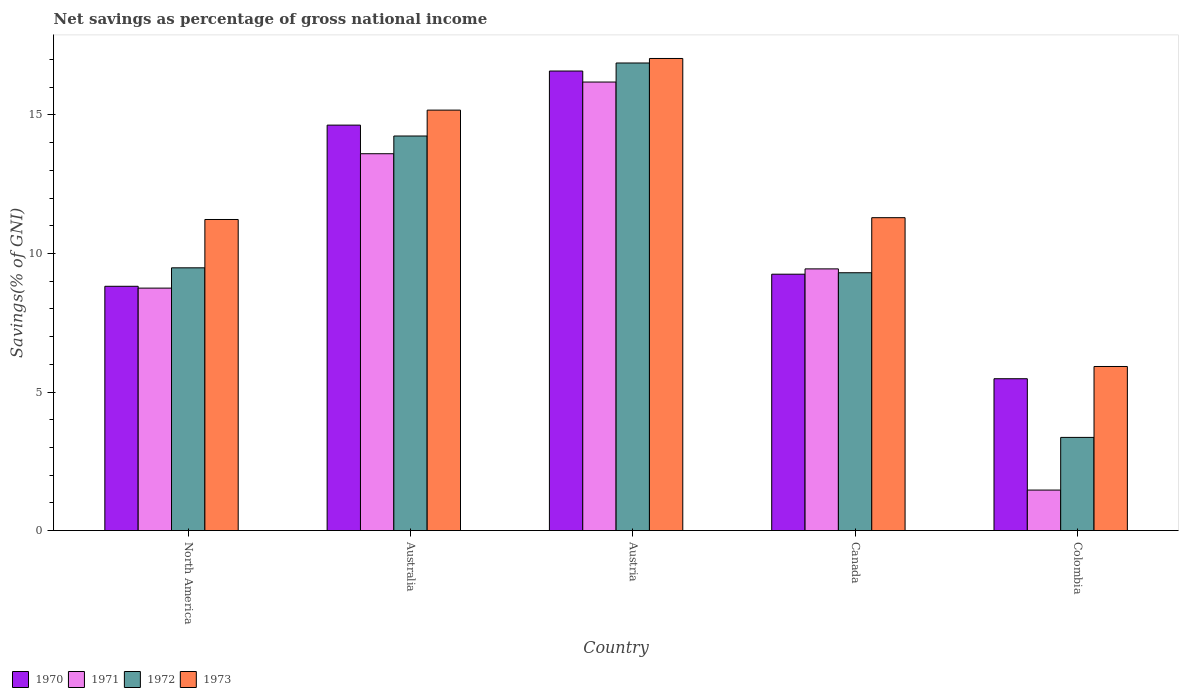Are the number of bars on each tick of the X-axis equal?
Your response must be concise. Yes. How many bars are there on the 3rd tick from the right?
Provide a short and direct response. 4. In how many cases, is the number of bars for a given country not equal to the number of legend labels?
Give a very brief answer. 0. What is the total savings in 1970 in Austria?
Your answer should be very brief. 16.59. Across all countries, what is the maximum total savings in 1970?
Your answer should be compact. 16.59. Across all countries, what is the minimum total savings in 1973?
Ensure brevity in your answer.  5.92. In which country was the total savings in 1971 maximum?
Your answer should be very brief. Austria. What is the total total savings in 1970 in the graph?
Keep it short and to the point. 54.78. What is the difference between the total savings in 1970 in Canada and that in North America?
Offer a very short reply. 0.44. What is the difference between the total savings in 1970 in North America and the total savings in 1971 in Australia?
Your answer should be compact. -4.78. What is the average total savings in 1970 per country?
Make the answer very short. 10.96. What is the difference between the total savings of/in 1970 and total savings of/in 1973 in Austria?
Ensure brevity in your answer.  -0.45. In how many countries, is the total savings in 1970 greater than 5 %?
Keep it short and to the point. 5. What is the ratio of the total savings in 1971 in Austria to that in Canada?
Provide a succinct answer. 1.71. Is the difference between the total savings in 1970 in Australia and North America greater than the difference between the total savings in 1973 in Australia and North America?
Provide a succinct answer. Yes. What is the difference between the highest and the second highest total savings in 1972?
Ensure brevity in your answer.  7.39. What is the difference between the highest and the lowest total savings in 1973?
Your answer should be compact. 11.12. In how many countries, is the total savings in 1971 greater than the average total savings in 1971 taken over all countries?
Offer a very short reply. 2. Is the sum of the total savings in 1971 in Australia and Austria greater than the maximum total savings in 1972 across all countries?
Provide a succinct answer. Yes. What does the 3rd bar from the left in Australia represents?
Your answer should be very brief. 1972. What does the 3rd bar from the right in Colombia represents?
Your answer should be compact. 1971. Is it the case that in every country, the sum of the total savings in 1973 and total savings in 1971 is greater than the total savings in 1972?
Offer a terse response. Yes. How many countries are there in the graph?
Ensure brevity in your answer.  5. What is the difference between two consecutive major ticks on the Y-axis?
Your answer should be compact. 5. Does the graph contain any zero values?
Provide a succinct answer. No. Does the graph contain grids?
Your answer should be very brief. No. Where does the legend appear in the graph?
Your response must be concise. Bottom left. How many legend labels are there?
Provide a short and direct response. 4. What is the title of the graph?
Ensure brevity in your answer.  Net savings as percentage of gross national income. Does "2001" appear as one of the legend labels in the graph?
Provide a short and direct response. No. What is the label or title of the X-axis?
Your response must be concise. Country. What is the label or title of the Y-axis?
Ensure brevity in your answer.  Savings(% of GNI). What is the Savings(% of GNI) of 1970 in North America?
Ensure brevity in your answer.  8.82. What is the Savings(% of GNI) of 1971 in North America?
Your response must be concise. 8.75. What is the Savings(% of GNI) in 1972 in North America?
Keep it short and to the point. 9.48. What is the Savings(% of GNI) in 1973 in North America?
Ensure brevity in your answer.  11.23. What is the Savings(% of GNI) in 1970 in Australia?
Ensure brevity in your answer.  14.63. What is the Savings(% of GNI) of 1971 in Australia?
Your answer should be very brief. 13.6. What is the Savings(% of GNI) of 1972 in Australia?
Provide a succinct answer. 14.24. What is the Savings(% of GNI) of 1973 in Australia?
Offer a very short reply. 15.18. What is the Savings(% of GNI) in 1970 in Austria?
Your answer should be compact. 16.59. What is the Savings(% of GNI) in 1971 in Austria?
Offer a very short reply. 16.19. What is the Savings(% of GNI) of 1972 in Austria?
Your answer should be very brief. 16.88. What is the Savings(% of GNI) of 1973 in Austria?
Your answer should be compact. 17.04. What is the Savings(% of GNI) of 1970 in Canada?
Offer a very short reply. 9.25. What is the Savings(% of GNI) of 1971 in Canada?
Your answer should be very brief. 9.45. What is the Savings(% of GNI) of 1972 in Canada?
Offer a very short reply. 9.31. What is the Savings(% of GNI) of 1973 in Canada?
Keep it short and to the point. 11.29. What is the Savings(% of GNI) in 1970 in Colombia?
Provide a succinct answer. 5.48. What is the Savings(% of GNI) of 1971 in Colombia?
Ensure brevity in your answer.  1.46. What is the Savings(% of GNI) of 1972 in Colombia?
Your response must be concise. 3.36. What is the Savings(% of GNI) in 1973 in Colombia?
Give a very brief answer. 5.92. Across all countries, what is the maximum Savings(% of GNI) in 1970?
Ensure brevity in your answer.  16.59. Across all countries, what is the maximum Savings(% of GNI) in 1971?
Your answer should be very brief. 16.19. Across all countries, what is the maximum Savings(% of GNI) in 1972?
Offer a terse response. 16.88. Across all countries, what is the maximum Savings(% of GNI) of 1973?
Your answer should be compact. 17.04. Across all countries, what is the minimum Savings(% of GNI) of 1970?
Provide a short and direct response. 5.48. Across all countries, what is the minimum Savings(% of GNI) of 1971?
Offer a very short reply. 1.46. Across all countries, what is the minimum Savings(% of GNI) in 1972?
Your answer should be compact. 3.36. Across all countries, what is the minimum Savings(% of GNI) in 1973?
Provide a succinct answer. 5.92. What is the total Savings(% of GNI) in 1970 in the graph?
Ensure brevity in your answer.  54.78. What is the total Savings(% of GNI) in 1971 in the graph?
Provide a succinct answer. 49.45. What is the total Savings(% of GNI) in 1972 in the graph?
Make the answer very short. 53.27. What is the total Savings(% of GNI) of 1973 in the graph?
Provide a succinct answer. 60.66. What is the difference between the Savings(% of GNI) of 1970 in North America and that in Australia?
Your answer should be very brief. -5.82. What is the difference between the Savings(% of GNI) of 1971 in North America and that in Australia?
Make the answer very short. -4.85. What is the difference between the Savings(% of GNI) in 1972 in North America and that in Australia?
Offer a very short reply. -4.76. What is the difference between the Savings(% of GNI) of 1973 in North America and that in Australia?
Give a very brief answer. -3.95. What is the difference between the Savings(% of GNI) of 1970 in North America and that in Austria?
Offer a very short reply. -7.77. What is the difference between the Savings(% of GNI) of 1971 in North America and that in Austria?
Offer a terse response. -7.44. What is the difference between the Savings(% of GNI) of 1972 in North America and that in Austria?
Give a very brief answer. -7.39. What is the difference between the Savings(% of GNI) in 1973 in North America and that in Austria?
Provide a short and direct response. -5.81. What is the difference between the Savings(% of GNI) of 1970 in North America and that in Canada?
Give a very brief answer. -0.44. What is the difference between the Savings(% of GNI) of 1971 in North America and that in Canada?
Keep it short and to the point. -0.69. What is the difference between the Savings(% of GNI) of 1972 in North America and that in Canada?
Make the answer very short. 0.18. What is the difference between the Savings(% of GNI) of 1973 in North America and that in Canada?
Provide a short and direct response. -0.07. What is the difference between the Savings(% of GNI) in 1970 in North America and that in Colombia?
Offer a very short reply. 3.34. What is the difference between the Savings(% of GNI) of 1971 in North America and that in Colombia?
Your answer should be compact. 7.29. What is the difference between the Savings(% of GNI) in 1972 in North America and that in Colombia?
Offer a terse response. 6.12. What is the difference between the Savings(% of GNI) of 1973 in North America and that in Colombia?
Ensure brevity in your answer.  5.31. What is the difference between the Savings(% of GNI) in 1970 in Australia and that in Austria?
Provide a short and direct response. -1.95. What is the difference between the Savings(% of GNI) of 1971 in Australia and that in Austria?
Provide a short and direct response. -2.59. What is the difference between the Savings(% of GNI) in 1972 in Australia and that in Austria?
Keep it short and to the point. -2.64. What is the difference between the Savings(% of GNI) in 1973 in Australia and that in Austria?
Offer a very short reply. -1.86. What is the difference between the Savings(% of GNI) in 1970 in Australia and that in Canada?
Give a very brief answer. 5.38. What is the difference between the Savings(% of GNI) of 1971 in Australia and that in Canada?
Provide a succinct answer. 4.16. What is the difference between the Savings(% of GNI) of 1972 in Australia and that in Canada?
Offer a terse response. 4.93. What is the difference between the Savings(% of GNI) in 1973 in Australia and that in Canada?
Give a very brief answer. 3.88. What is the difference between the Savings(% of GNI) of 1970 in Australia and that in Colombia?
Provide a succinct answer. 9.15. What is the difference between the Savings(% of GNI) in 1971 in Australia and that in Colombia?
Ensure brevity in your answer.  12.14. What is the difference between the Savings(% of GNI) in 1972 in Australia and that in Colombia?
Keep it short and to the point. 10.88. What is the difference between the Savings(% of GNI) of 1973 in Australia and that in Colombia?
Your answer should be very brief. 9.25. What is the difference between the Savings(% of GNI) in 1970 in Austria and that in Canada?
Provide a short and direct response. 7.33. What is the difference between the Savings(% of GNI) in 1971 in Austria and that in Canada?
Make the answer very short. 6.74. What is the difference between the Savings(% of GNI) of 1972 in Austria and that in Canada?
Provide a succinct answer. 7.57. What is the difference between the Savings(% of GNI) in 1973 in Austria and that in Canada?
Offer a very short reply. 5.75. What is the difference between the Savings(% of GNI) in 1970 in Austria and that in Colombia?
Your answer should be compact. 11.11. What is the difference between the Savings(% of GNI) of 1971 in Austria and that in Colombia?
Make the answer very short. 14.73. What is the difference between the Savings(% of GNI) in 1972 in Austria and that in Colombia?
Your answer should be compact. 13.51. What is the difference between the Savings(% of GNI) of 1973 in Austria and that in Colombia?
Offer a terse response. 11.12. What is the difference between the Savings(% of GNI) in 1970 in Canada and that in Colombia?
Keep it short and to the point. 3.77. What is the difference between the Savings(% of GNI) of 1971 in Canada and that in Colombia?
Give a very brief answer. 7.98. What is the difference between the Savings(% of GNI) of 1972 in Canada and that in Colombia?
Give a very brief answer. 5.94. What is the difference between the Savings(% of GNI) in 1973 in Canada and that in Colombia?
Your response must be concise. 5.37. What is the difference between the Savings(% of GNI) of 1970 in North America and the Savings(% of GNI) of 1971 in Australia?
Make the answer very short. -4.78. What is the difference between the Savings(% of GNI) in 1970 in North America and the Savings(% of GNI) in 1972 in Australia?
Make the answer very short. -5.42. What is the difference between the Savings(% of GNI) of 1970 in North America and the Savings(% of GNI) of 1973 in Australia?
Offer a terse response. -6.36. What is the difference between the Savings(% of GNI) of 1971 in North America and the Savings(% of GNI) of 1972 in Australia?
Your response must be concise. -5.49. What is the difference between the Savings(% of GNI) of 1971 in North America and the Savings(% of GNI) of 1973 in Australia?
Your answer should be compact. -6.42. What is the difference between the Savings(% of GNI) in 1972 in North America and the Savings(% of GNI) in 1973 in Australia?
Your answer should be very brief. -5.69. What is the difference between the Savings(% of GNI) of 1970 in North America and the Savings(% of GNI) of 1971 in Austria?
Keep it short and to the point. -7.37. What is the difference between the Savings(% of GNI) of 1970 in North America and the Savings(% of GNI) of 1972 in Austria?
Ensure brevity in your answer.  -8.06. What is the difference between the Savings(% of GNI) in 1970 in North America and the Savings(% of GNI) in 1973 in Austria?
Offer a terse response. -8.22. What is the difference between the Savings(% of GNI) of 1971 in North America and the Savings(% of GNI) of 1972 in Austria?
Keep it short and to the point. -8.12. What is the difference between the Savings(% of GNI) of 1971 in North America and the Savings(% of GNI) of 1973 in Austria?
Your response must be concise. -8.29. What is the difference between the Savings(% of GNI) in 1972 in North America and the Savings(% of GNI) in 1973 in Austria?
Give a very brief answer. -7.56. What is the difference between the Savings(% of GNI) in 1970 in North America and the Savings(% of GNI) in 1971 in Canada?
Offer a terse response. -0.63. What is the difference between the Savings(% of GNI) in 1970 in North America and the Savings(% of GNI) in 1972 in Canada?
Your response must be concise. -0.49. What is the difference between the Savings(% of GNI) in 1970 in North America and the Savings(% of GNI) in 1973 in Canada?
Make the answer very short. -2.48. What is the difference between the Savings(% of GNI) of 1971 in North America and the Savings(% of GNI) of 1972 in Canada?
Your answer should be very brief. -0.55. What is the difference between the Savings(% of GNI) of 1971 in North America and the Savings(% of GNI) of 1973 in Canada?
Give a very brief answer. -2.54. What is the difference between the Savings(% of GNI) in 1972 in North America and the Savings(% of GNI) in 1973 in Canada?
Ensure brevity in your answer.  -1.81. What is the difference between the Savings(% of GNI) of 1970 in North America and the Savings(% of GNI) of 1971 in Colombia?
Your answer should be very brief. 7.36. What is the difference between the Savings(% of GNI) of 1970 in North America and the Savings(% of GNI) of 1972 in Colombia?
Provide a short and direct response. 5.45. What is the difference between the Savings(% of GNI) of 1970 in North America and the Savings(% of GNI) of 1973 in Colombia?
Your response must be concise. 2.89. What is the difference between the Savings(% of GNI) in 1971 in North America and the Savings(% of GNI) in 1972 in Colombia?
Make the answer very short. 5.39. What is the difference between the Savings(% of GNI) in 1971 in North America and the Savings(% of GNI) in 1973 in Colombia?
Make the answer very short. 2.83. What is the difference between the Savings(% of GNI) of 1972 in North America and the Savings(% of GNI) of 1973 in Colombia?
Ensure brevity in your answer.  3.56. What is the difference between the Savings(% of GNI) in 1970 in Australia and the Savings(% of GNI) in 1971 in Austria?
Provide a short and direct response. -1.55. What is the difference between the Savings(% of GNI) in 1970 in Australia and the Savings(% of GNI) in 1972 in Austria?
Offer a very short reply. -2.24. What is the difference between the Savings(% of GNI) in 1970 in Australia and the Savings(% of GNI) in 1973 in Austria?
Provide a succinct answer. -2.4. What is the difference between the Savings(% of GNI) of 1971 in Australia and the Savings(% of GNI) of 1972 in Austria?
Ensure brevity in your answer.  -3.27. What is the difference between the Savings(% of GNI) in 1971 in Australia and the Savings(% of GNI) in 1973 in Austria?
Your response must be concise. -3.44. What is the difference between the Savings(% of GNI) in 1972 in Australia and the Savings(% of GNI) in 1973 in Austria?
Offer a terse response. -2.8. What is the difference between the Savings(% of GNI) in 1970 in Australia and the Savings(% of GNI) in 1971 in Canada?
Give a very brief answer. 5.19. What is the difference between the Savings(% of GNI) of 1970 in Australia and the Savings(% of GNI) of 1972 in Canada?
Give a very brief answer. 5.33. What is the difference between the Savings(% of GNI) in 1970 in Australia and the Savings(% of GNI) in 1973 in Canada?
Give a very brief answer. 3.34. What is the difference between the Savings(% of GNI) in 1971 in Australia and the Savings(% of GNI) in 1972 in Canada?
Offer a terse response. 4.3. What is the difference between the Savings(% of GNI) in 1971 in Australia and the Savings(% of GNI) in 1973 in Canada?
Keep it short and to the point. 2.31. What is the difference between the Savings(% of GNI) of 1972 in Australia and the Savings(% of GNI) of 1973 in Canada?
Offer a very short reply. 2.95. What is the difference between the Savings(% of GNI) of 1970 in Australia and the Savings(% of GNI) of 1971 in Colombia?
Keep it short and to the point. 13.17. What is the difference between the Savings(% of GNI) of 1970 in Australia and the Savings(% of GNI) of 1972 in Colombia?
Provide a short and direct response. 11.27. What is the difference between the Savings(% of GNI) of 1970 in Australia and the Savings(% of GNI) of 1973 in Colombia?
Give a very brief answer. 8.71. What is the difference between the Savings(% of GNI) in 1971 in Australia and the Savings(% of GNI) in 1972 in Colombia?
Provide a succinct answer. 10.24. What is the difference between the Savings(% of GNI) in 1971 in Australia and the Savings(% of GNI) in 1973 in Colombia?
Give a very brief answer. 7.68. What is the difference between the Savings(% of GNI) of 1972 in Australia and the Savings(% of GNI) of 1973 in Colombia?
Your response must be concise. 8.32. What is the difference between the Savings(% of GNI) in 1970 in Austria and the Savings(% of GNI) in 1971 in Canada?
Your response must be concise. 7.14. What is the difference between the Savings(% of GNI) in 1970 in Austria and the Savings(% of GNI) in 1972 in Canada?
Your response must be concise. 7.28. What is the difference between the Savings(% of GNI) in 1970 in Austria and the Savings(% of GNI) in 1973 in Canada?
Your response must be concise. 5.29. What is the difference between the Savings(% of GNI) of 1971 in Austria and the Savings(% of GNI) of 1972 in Canada?
Provide a succinct answer. 6.88. What is the difference between the Savings(% of GNI) in 1971 in Austria and the Savings(% of GNI) in 1973 in Canada?
Give a very brief answer. 4.9. What is the difference between the Savings(% of GNI) in 1972 in Austria and the Savings(% of GNI) in 1973 in Canada?
Ensure brevity in your answer.  5.58. What is the difference between the Savings(% of GNI) in 1970 in Austria and the Savings(% of GNI) in 1971 in Colombia?
Your response must be concise. 15.12. What is the difference between the Savings(% of GNI) in 1970 in Austria and the Savings(% of GNI) in 1972 in Colombia?
Your answer should be very brief. 13.22. What is the difference between the Savings(% of GNI) in 1970 in Austria and the Savings(% of GNI) in 1973 in Colombia?
Give a very brief answer. 10.66. What is the difference between the Savings(% of GNI) of 1971 in Austria and the Savings(% of GNI) of 1972 in Colombia?
Offer a very short reply. 12.83. What is the difference between the Savings(% of GNI) of 1971 in Austria and the Savings(% of GNI) of 1973 in Colombia?
Ensure brevity in your answer.  10.27. What is the difference between the Savings(% of GNI) in 1972 in Austria and the Savings(% of GNI) in 1973 in Colombia?
Offer a terse response. 10.95. What is the difference between the Savings(% of GNI) in 1970 in Canada and the Savings(% of GNI) in 1971 in Colombia?
Your response must be concise. 7.79. What is the difference between the Savings(% of GNI) in 1970 in Canada and the Savings(% of GNI) in 1972 in Colombia?
Give a very brief answer. 5.89. What is the difference between the Savings(% of GNI) of 1970 in Canada and the Savings(% of GNI) of 1973 in Colombia?
Offer a very short reply. 3.33. What is the difference between the Savings(% of GNI) in 1971 in Canada and the Savings(% of GNI) in 1972 in Colombia?
Your answer should be compact. 6.08. What is the difference between the Savings(% of GNI) in 1971 in Canada and the Savings(% of GNI) in 1973 in Colombia?
Offer a very short reply. 3.52. What is the difference between the Savings(% of GNI) in 1972 in Canada and the Savings(% of GNI) in 1973 in Colombia?
Offer a very short reply. 3.38. What is the average Savings(% of GNI) in 1970 per country?
Offer a very short reply. 10.96. What is the average Savings(% of GNI) of 1971 per country?
Ensure brevity in your answer.  9.89. What is the average Savings(% of GNI) of 1972 per country?
Offer a very short reply. 10.65. What is the average Savings(% of GNI) of 1973 per country?
Your response must be concise. 12.13. What is the difference between the Savings(% of GNI) of 1970 and Savings(% of GNI) of 1971 in North America?
Keep it short and to the point. 0.07. What is the difference between the Savings(% of GNI) of 1970 and Savings(% of GNI) of 1972 in North America?
Make the answer very short. -0.67. What is the difference between the Savings(% of GNI) of 1970 and Savings(% of GNI) of 1973 in North America?
Your response must be concise. -2.41. What is the difference between the Savings(% of GNI) in 1971 and Savings(% of GNI) in 1972 in North America?
Provide a short and direct response. -0.73. What is the difference between the Savings(% of GNI) of 1971 and Savings(% of GNI) of 1973 in North America?
Make the answer very short. -2.48. What is the difference between the Savings(% of GNI) in 1972 and Savings(% of GNI) in 1973 in North America?
Your answer should be compact. -1.74. What is the difference between the Savings(% of GNI) of 1970 and Savings(% of GNI) of 1971 in Australia?
Your answer should be compact. 1.03. What is the difference between the Savings(% of GNI) of 1970 and Savings(% of GNI) of 1972 in Australia?
Your answer should be very brief. 0.39. What is the difference between the Savings(% of GNI) of 1970 and Savings(% of GNI) of 1973 in Australia?
Offer a very short reply. -0.54. What is the difference between the Savings(% of GNI) in 1971 and Savings(% of GNI) in 1972 in Australia?
Make the answer very short. -0.64. What is the difference between the Savings(% of GNI) in 1971 and Savings(% of GNI) in 1973 in Australia?
Give a very brief answer. -1.57. What is the difference between the Savings(% of GNI) of 1972 and Savings(% of GNI) of 1973 in Australia?
Provide a short and direct response. -0.93. What is the difference between the Savings(% of GNI) in 1970 and Savings(% of GNI) in 1971 in Austria?
Give a very brief answer. 0.4. What is the difference between the Savings(% of GNI) in 1970 and Savings(% of GNI) in 1972 in Austria?
Make the answer very short. -0.29. What is the difference between the Savings(% of GNI) in 1970 and Savings(% of GNI) in 1973 in Austria?
Give a very brief answer. -0.45. What is the difference between the Savings(% of GNI) in 1971 and Savings(% of GNI) in 1972 in Austria?
Provide a succinct answer. -0.69. What is the difference between the Savings(% of GNI) of 1971 and Savings(% of GNI) of 1973 in Austria?
Offer a terse response. -0.85. What is the difference between the Savings(% of GNI) of 1972 and Savings(% of GNI) of 1973 in Austria?
Offer a very short reply. -0.16. What is the difference between the Savings(% of GNI) of 1970 and Savings(% of GNI) of 1971 in Canada?
Your answer should be very brief. -0.19. What is the difference between the Savings(% of GNI) in 1970 and Savings(% of GNI) in 1972 in Canada?
Your answer should be compact. -0.05. What is the difference between the Savings(% of GNI) of 1970 and Savings(% of GNI) of 1973 in Canada?
Give a very brief answer. -2.04. What is the difference between the Savings(% of GNI) in 1971 and Savings(% of GNI) in 1972 in Canada?
Ensure brevity in your answer.  0.14. What is the difference between the Savings(% of GNI) in 1971 and Savings(% of GNI) in 1973 in Canada?
Your response must be concise. -1.85. What is the difference between the Savings(% of GNI) in 1972 and Savings(% of GNI) in 1973 in Canada?
Keep it short and to the point. -1.99. What is the difference between the Savings(% of GNI) of 1970 and Savings(% of GNI) of 1971 in Colombia?
Your answer should be compact. 4.02. What is the difference between the Savings(% of GNI) of 1970 and Savings(% of GNI) of 1972 in Colombia?
Your answer should be very brief. 2.12. What is the difference between the Savings(% of GNI) of 1970 and Savings(% of GNI) of 1973 in Colombia?
Give a very brief answer. -0.44. What is the difference between the Savings(% of GNI) of 1971 and Savings(% of GNI) of 1972 in Colombia?
Provide a short and direct response. -1.9. What is the difference between the Savings(% of GNI) of 1971 and Savings(% of GNI) of 1973 in Colombia?
Your answer should be compact. -4.46. What is the difference between the Savings(% of GNI) in 1972 and Savings(% of GNI) in 1973 in Colombia?
Your answer should be compact. -2.56. What is the ratio of the Savings(% of GNI) in 1970 in North America to that in Australia?
Provide a succinct answer. 0.6. What is the ratio of the Savings(% of GNI) in 1971 in North America to that in Australia?
Your answer should be compact. 0.64. What is the ratio of the Savings(% of GNI) in 1972 in North America to that in Australia?
Keep it short and to the point. 0.67. What is the ratio of the Savings(% of GNI) in 1973 in North America to that in Australia?
Provide a short and direct response. 0.74. What is the ratio of the Savings(% of GNI) of 1970 in North America to that in Austria?
Provide a succinct answer. 0.53. What is the ratio of the Savings(% of GNI) in 1971 in North America to that in Austria?
Give a very brief answer. 0.54. What is the ratio of the Savings(% of GNI) of 1972 in North America to that in Austria?
Ensure brevity in your answer.  0.56. What is the ratio of the Savings(% of GNI) in 1973 in North America to that in Austria?
Your response must be concise. 0.66. What is the ratio of the Savings(% of GNI) of 1970 in North America to that in Canada?
Provide a short and direct response. 0.95. What is the ratio of the Savings(% of GNI) in 1971 in North America to that in Canada?
Your answer should be compact. 0.93. What is the ratio of the Savings(% of GNI) in 1972 in North America to that in Canada?
Provide a short and direct response. 1.02. What is the ratio of the Savings(% of GNI) of 1973 in North America to that in Canada?
Give a very brief answer. 0.99. What is the ratio of the Savings(% of GNI) of 1970 in North America to that in Colombia?
Keep it short and to the point. 1.61. What is the ratio of the Savings(% of GNI) of 1971 in North America to that in Colombia?
Your response must be concise. 5.98. What is the ratio of the Savings(% of GNI) of 1972 in North America to that in Colombia?
Your answer should be very brief. 2.82. What is the ratio of the Savings(% of GNI) of 1973 in North America to that in Colombia?
Ensure brevity in your answer.  1.9. What is the ratio of the Savings(% of GNI) of 1970 in Australia to that in Austria?
Your response must be concise. 0.88. What is the ratio of the Savings(% of GNI) of 1971 in Australia to that in Austria?
Offer a very short reply. 0.84. What is the ratio of the Savings(% of GNI) of 1972 in Australia to that in Austria?
Offer a very short reply. 0.84. What is the ratio of the Savings(% of GNI) in 1973 in Australia to that in Austria?
Your answer should be very brief. 0.89. What is the ratio of the Savings(% of GNI) in 1970 in Australia to that in Canada?
Your answer should be compact. 1.58. What is the ratio of the Savings(% of GNI) in 1971 in Australia to that in Canada?
Provide a succinct answer. 1.44. What is the ratio of the Savings(% of GNI) in 1972 in Australia to that in Canada?
Your answer should be compact. 1.53. What is the ratio of the Savings(% of GNI) of 1973 in Australia to that in Canada?
Provide a succinct answer. 1.34. What is the ratio of the Savings(% of GNI) in 1970 in Australia to that in Colombia?
Provide a succinct answer. 2.67. What is the ratio of the Savings(% of GNI) of 1971 in Australia to that in Colombia?
Give a very brief answer. 9.3. What is the ratio of the Savings(% of GNI) in 1972 in Australia to that in Colombia?
Your answer should be very brief. 4.23. What is the ratio of the Savings(% of GNI) in 1973 in Australia to that in Colombia?
Keep it short and to the point. 2.56. What is the ratio of the Savings(% of GNI) of 1970 in Austria to that in Canada?
Provide a succinct answer. 1.79. What is the ratio of the Savings(% of GNI) of 1971 in Austria to that in Canada?
Keep it short and to the point. 1.71. What is the ratio of the Savings(% of GNI) of 1972 in Austria to that in Canada?
Provide a succinct answer. 1.81. What is the ratio of the Savings(% of GNI) in 1973 in Austria to that in Canada?
Keep it short and to the point. 1.51. What is the ratio of the Savings(% of GNI) of 1970 in Austria to that in Colombia?
Ensure brevity in your answer.  3.03. What is the ratio of the Savings(% of GNI) in 1971 in Austria to that in Colombia?
Your answer should be very brief. 11.07. What is the ratio of the Savings(% of GNI) of 1972 in Austria to that in Colombia?
Offer a very short reply. 5.02. What is the ratio of the Savings(% of GNI) of 1973 in Austria to that in Colombia?
Keep it short and to the point. 2.88. What is the ratio of the Savings(% of GNI) of 1970 in Canada to that in Colombia?
Offer a very short reply. 1.69. What is the ratio of the Savings(% of GNI) in 1971 in Canada to that in Colombia?
Your response must be concise. 6.46. What is the ratio of the Savings(% of GNI) in 1972 in Canada to that in Colombia?
Offer a very short reply. 2.77. What is the ratio of the Savings(% of GNI) in 1973 in Canada to that in Colombia?
Provide a short and direct response. 1.91. What is the difference between the highest and the second highest Savings(% of GNI) in 1970?
Keep it short and to the point. 1.95. What is the difference between the highest and the second highest Savings(% of GNI) of 1971?
Give a very brief answer. 2.59. What is the difference between the highest and the second highest Savings(% of GNI) of 1972?
Provide a short and direct response. 2.64. What is the difference between the highest and the second highest Savings(% of GNI) in 1973?
Offer a very short reply. 1.86. What is the difference between the highest and the lowest Savings(% of GNI) in 1970?
Offer a terse response. 11.11. What is the difference between the highest and the lowest Savings(% of GNI) of 1971?
Provide a short and direct response. 14.73. What is the difference between the highest and the lowest Savings(% of GNI) in 1972?
Provide a short and direct response. 13.51. What is the difference between the highest and the lowest Savings(% of GNI) of 1973?
Make the answer very short. 11.12. 